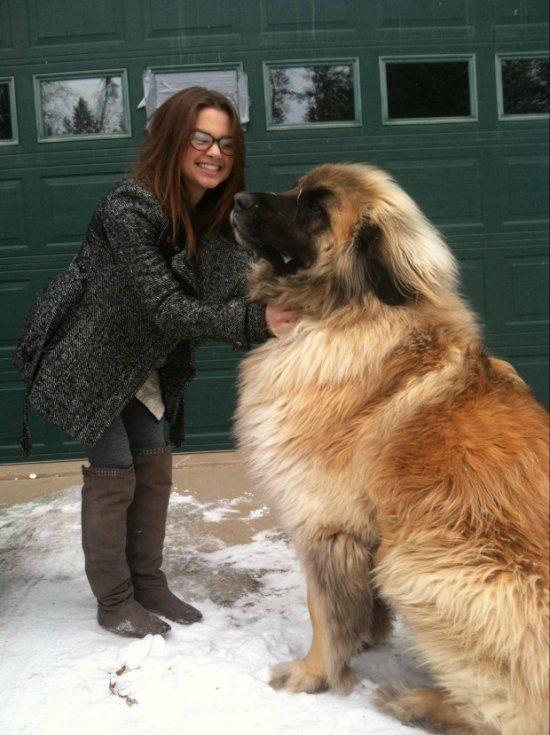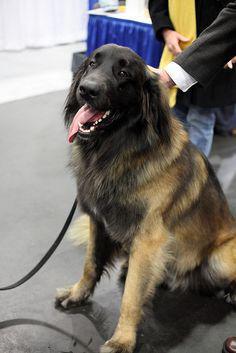The first image is the image on the left, the second image is the image on the right. Given the left and right images, does the statement "There is a woman with a large dog in the image on the left" hold true? Answer yes or no. Yes. 